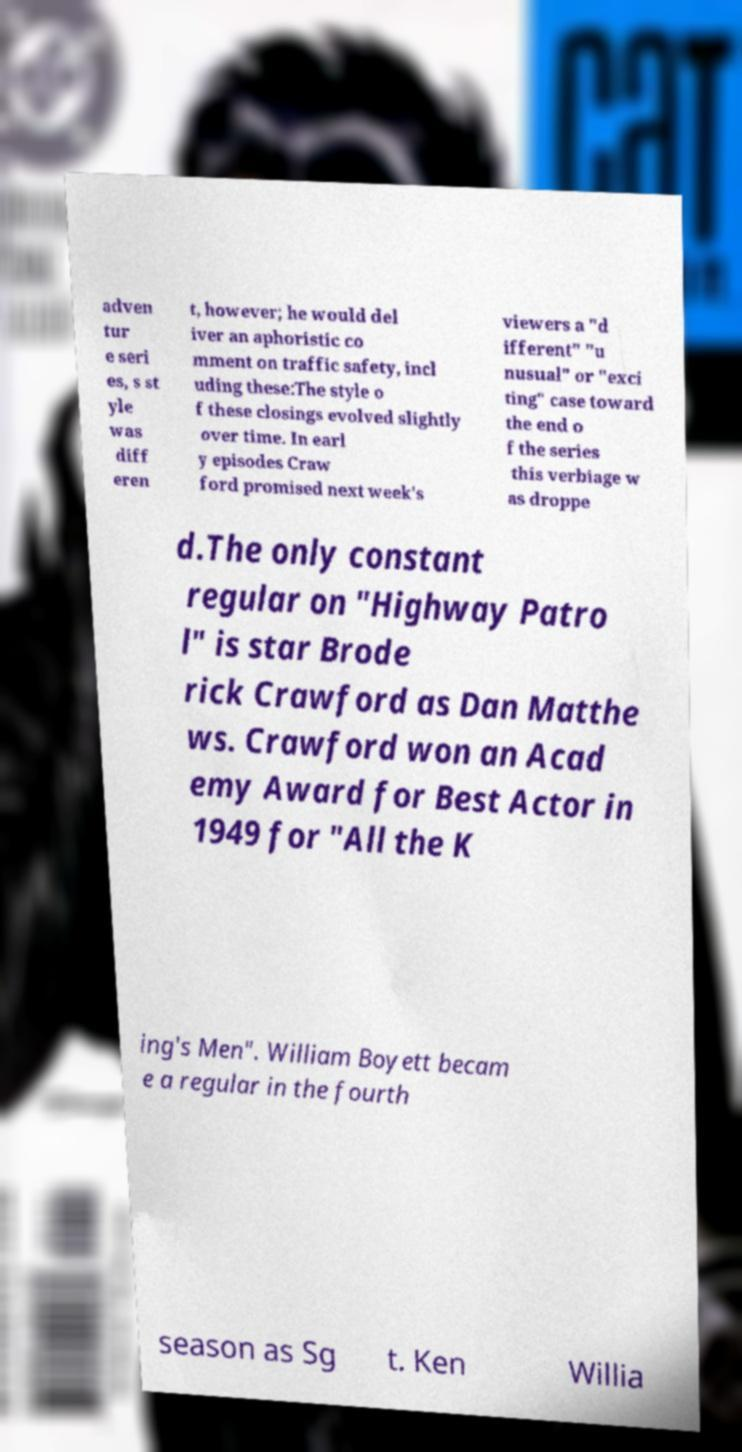Could you assist in decoding the text presented in this image and type it out clearly? adven tur e seri es, s st yle was diff eren t, however; he would del iver an aphoristic co mment on traffic safety, incl uding these:The style o f these closings evolved slightly over time. In earl y episodes Craw ford promised next week's viewers a "d ifferent" "u nusual" or "exci ting" case toward the end o f the series this verbiage w as droppe d.The only constant regular on "Highway Patro l" is star Brode rick Crawford as Dan Matthe ws. Crawford won an Acad emy Award for Best Actor in 1949 for "All the K ing's Men". William Boyett becam e a regular in the fourth season as Sg t. Ken Willia 